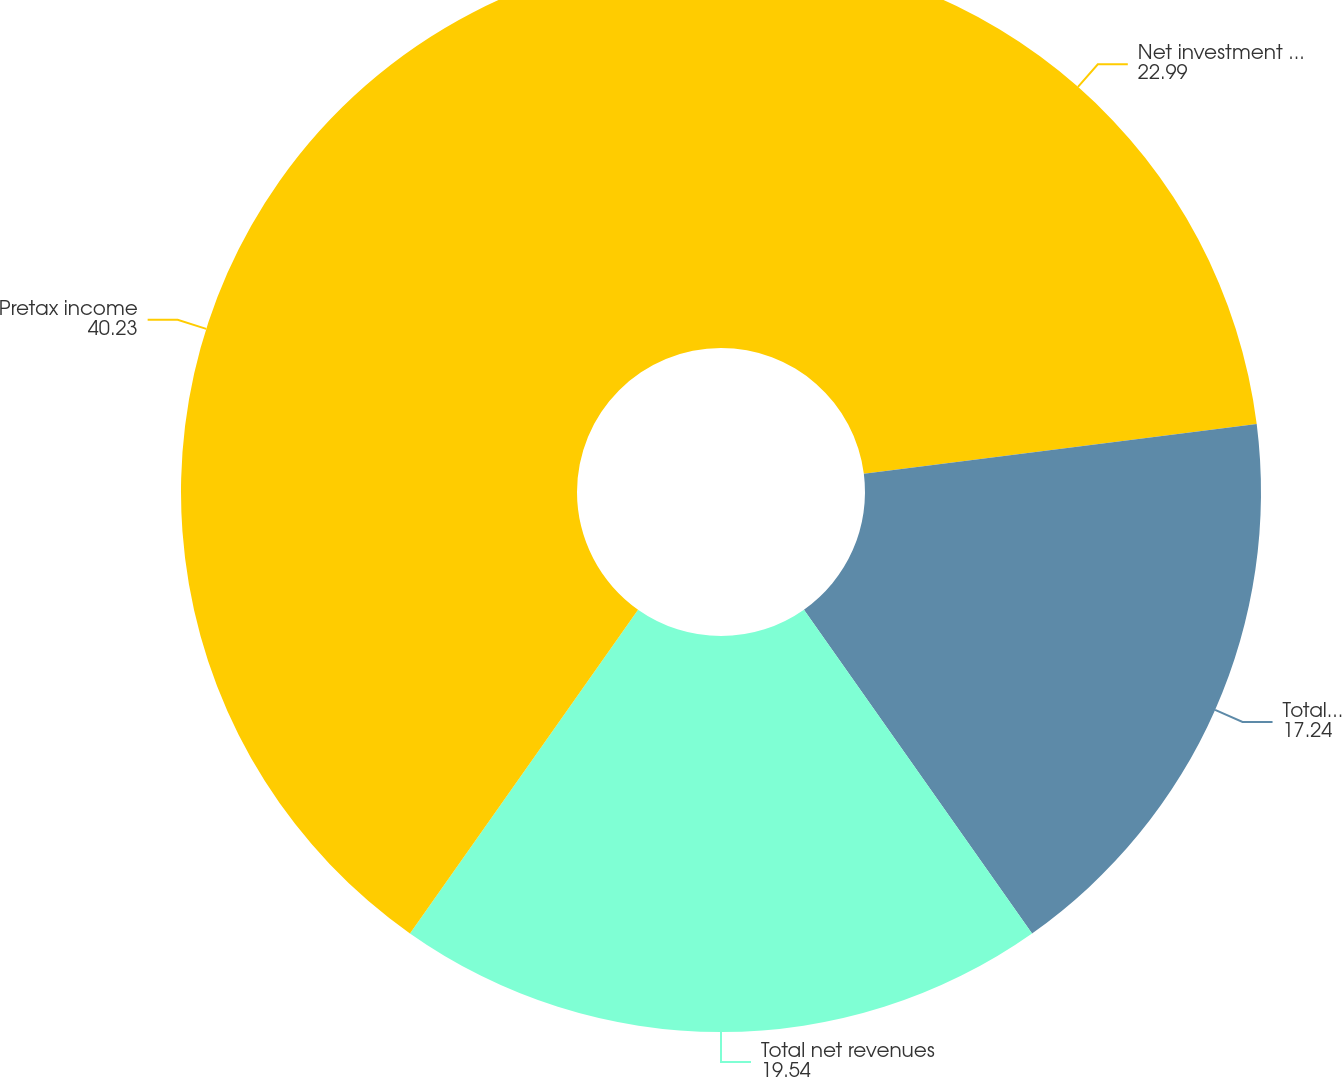<chart> <loc_0><loc_0><loc_500><loc_500><pie_chart><fcel>Net investment income<fcel>Total revenues<fcel>Total net revenues<fcel>Pretax income<nl><fcel>22.99%<fcel>17.24%<fcel>19.54%<fcel>40.23%<nl></chart> 